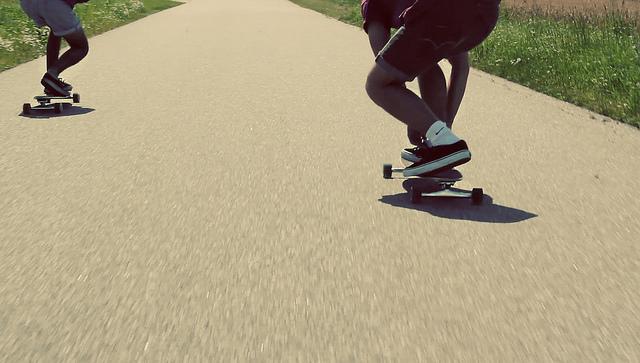Why are there two skaters?
Give a very brief answer. Friends. Which border is ahead?
Be succinct. One on left. What kind of traction do the wheels have on this skateboard in the photo?
Short answer required. Good. What gender are the skaters?
Concise answer only. Male. 